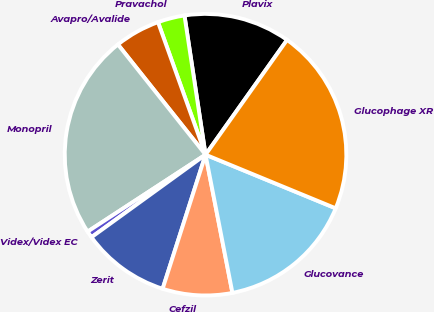Convert chart. <chart><loc_0><loc_0><loc_500><loc_500><pie_chart><fcel>Plavix<fcel>Pravachol<fcel>Avapro/Avalide<fcel>Monopril<fcel>Videx/Videx EC<fcel>Zerit<fcel>Cefzil<fcel>Glucovance<fcel>Glucophage XR<nl><fcel>12.22%<fcel>3.09%<fcel>5.21%<fcel>23.51%<fcel>0.77%<fcel>10.1%<fcel>7.99%<fcel>15.72%<fcel>21.39%<nl></chart> 